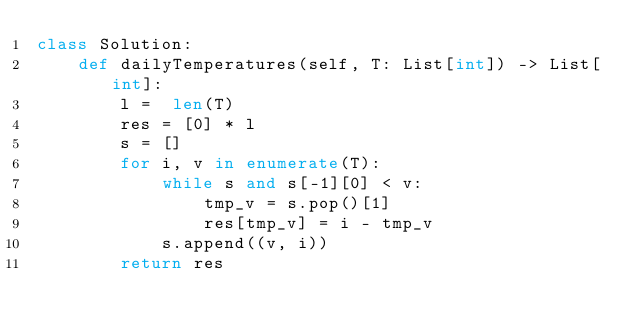Convert code to text. <code><loc_0><loc_0><loc_500><loc_500><_Python_>class Solution:
    def dailyTemperatures(self, T: List[int]) -> List[int]:
        l =  len(T)
        res = [0] * l
        s = []
        for i, v in enumerate(T):
            while s and s[-1][0] < v:
                tmp_v = s.pop()[1]
                res[tmp_v] = i - tmp_v 
            s.append((v, i))
        return res</code> 